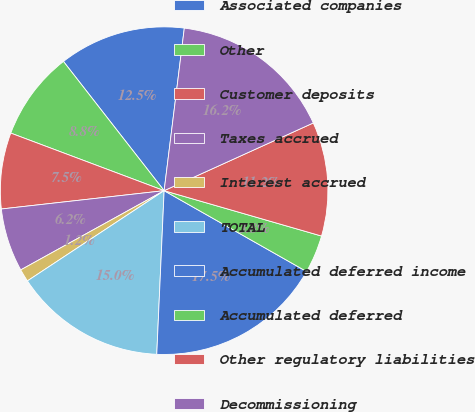<chart> <loc_0><loc_0><loc_500><loc_500><pie_chart><fcel>Associated companies<fcel>Other<fcel>Customer deposits<fcel>Taxes accrued<fcel>Interest accrued<fcel>TOTAL<fcel>Accumulated deferred income<fcel>Accumulated deferred<fcel>Other regulatory liabilities<fcel>Decommissioning<nl><fcel>12.5%<fcel>8.75%<fcel>7.5%<fcel>6.25%<fcel>1.25%<fcel>15.0%<fcel>17.5%<fcel>3.75%<fcel>11.25%<fcel>16.25%<nl></chart> 